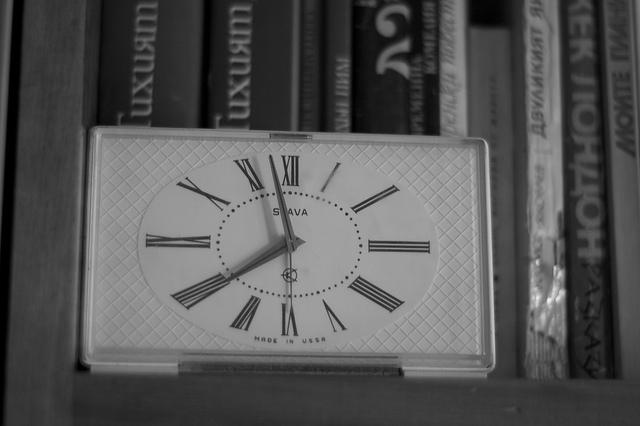What time does the clock read?
Give a very brief answer. 7:58. Is the Roman numerals?
Keep it brief. Yes. What time is there on the clock?
Keep it brief. 7:58. Is this clock probably showing local time rather than a different city's time?
Give a very brief answer. Yes. What shape is the hour hand?
Concise answer only. Triangle. Where was this clock made?
Give a very brief answer. Ussr. Is the time 8:00?
Write a very short answer. No. What time was this picture taken?
Keep it brief. 7:58. Could this be a clock in a restaurant?
Keep it brief. No. Is the clock built into the wall?
Quick response, please. No. What color is the clock?
Quick response, please. White. What time is it?
Quick response, please. 7:58. What time is on the clock?
Write a very short answer. 8:58. What country is the reader of the books probably from?
Concise answer only. Russia. What time does the clock say?
Quick response, please. 11:40. 